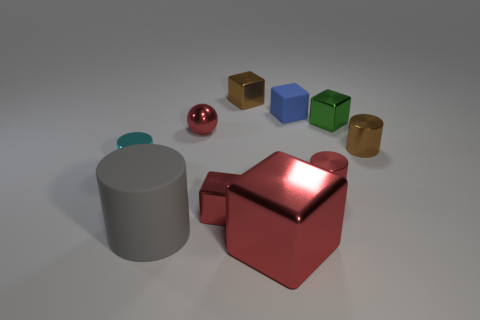Subtract all large cylinders. How many cylinders are left? 3 Subtract all green cylinders. How many red cubes are left? 2 Subtract all gray cylinders. How many cylinders are left? 3 Subtract 2 cylinders. How many cylinders are left? 2 Subtract all cylinders. How many objects are left? 6 Subtract all cyan cylinders. Subtract all large gray rubber objects. How many objects are left? 8 Add 7 big shiny things. How many big shiny things are left? 8 Add 7 big gray cylinders. How many big gray cylinders exist? 8 Subtract 1 brown cylinders. How many objects are left? 9 Subtract all purple cylinders. Subtract all gray blocks. How many cylinders are left? 4 